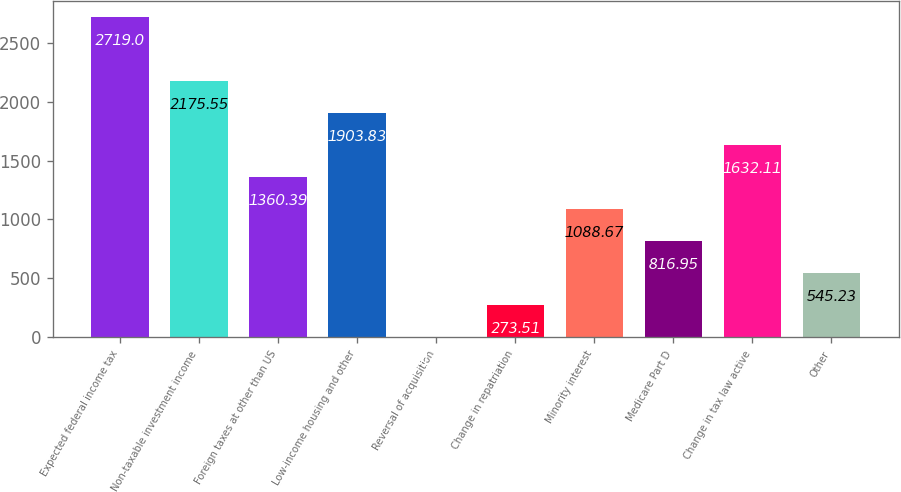Convert chart to OTSL. <chart><loc_0><loc_0><loc_500><loc_500><bar_chart><fcel>Expected federal income tax<fcel>Non-taxable investment income<fcel>Foreign taxes at other than US<fcel>Low-income housing and other<fcel>Reversal of acquisition<fcel>Change in repatriation<fcel>Minority interest<fcel>Medicare Part D<fcel>Change in tax law active<fcel>Other<nl><fcel>2719<fcel>2175.55<fcel>1360.39<fcel>1903.83<fcel>1.79<fcel>273.51<fcel>1088.67<fcel>816.95<fcel>1632.11<fcel>545.23<nl></chart> 